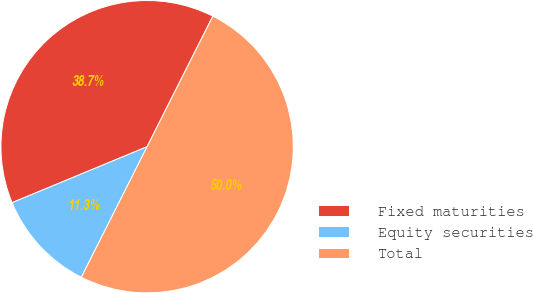Convert chart. <chart><loc_0><loc_0><loc_500><loc_500><pie_chart><fcel>Fixed maturities<fcel>Equity securities<fcel>Total<nl><fcel>38.68%<fcel>11.32%<fcel>50.0%<nl></chart> 